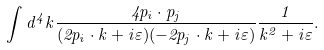<formula> <loc_0><loc_0><loc_500><loc_500>\int d ^ { 4 } k \frac { 4 p _ { i } \cdot p _ { j } } { ( 2 p _ { i } \cdot k + i \varepsilon ) ( - 2 p _ { j } \cdot k + i \varepsilon ) } \frac { 1 } { k ^ { 2 } + i \varepsilon } .</formula> 